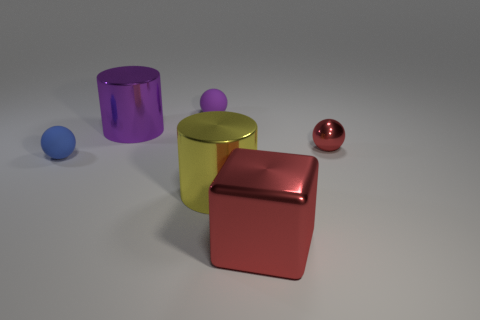Subtract all matte balls. How many balls are left? 1 Subtract all cylinders. How many objects are left? 4 Add 3 tiny shiny spheres. How many objects exist? 9 Subtract all cyan spheres. Subtract all blue blocks. How many spheres are left? 3 Subtract 0 gray cubes. How many objects are left? 6 Subtract all cyan cylinders. Subtract all big purple metallic objects. How many objects are left? 5 Add 1 spheres. How many spheres are left? 4 Add 3 small blue cylinders. How many small blue cylinders exist? 3 